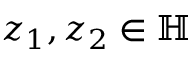<formula> <loc_0><loc_0><loc_500><loc_500>z _ { 1 } , z _ { 2 } \in \mathbb { H }</formula> 